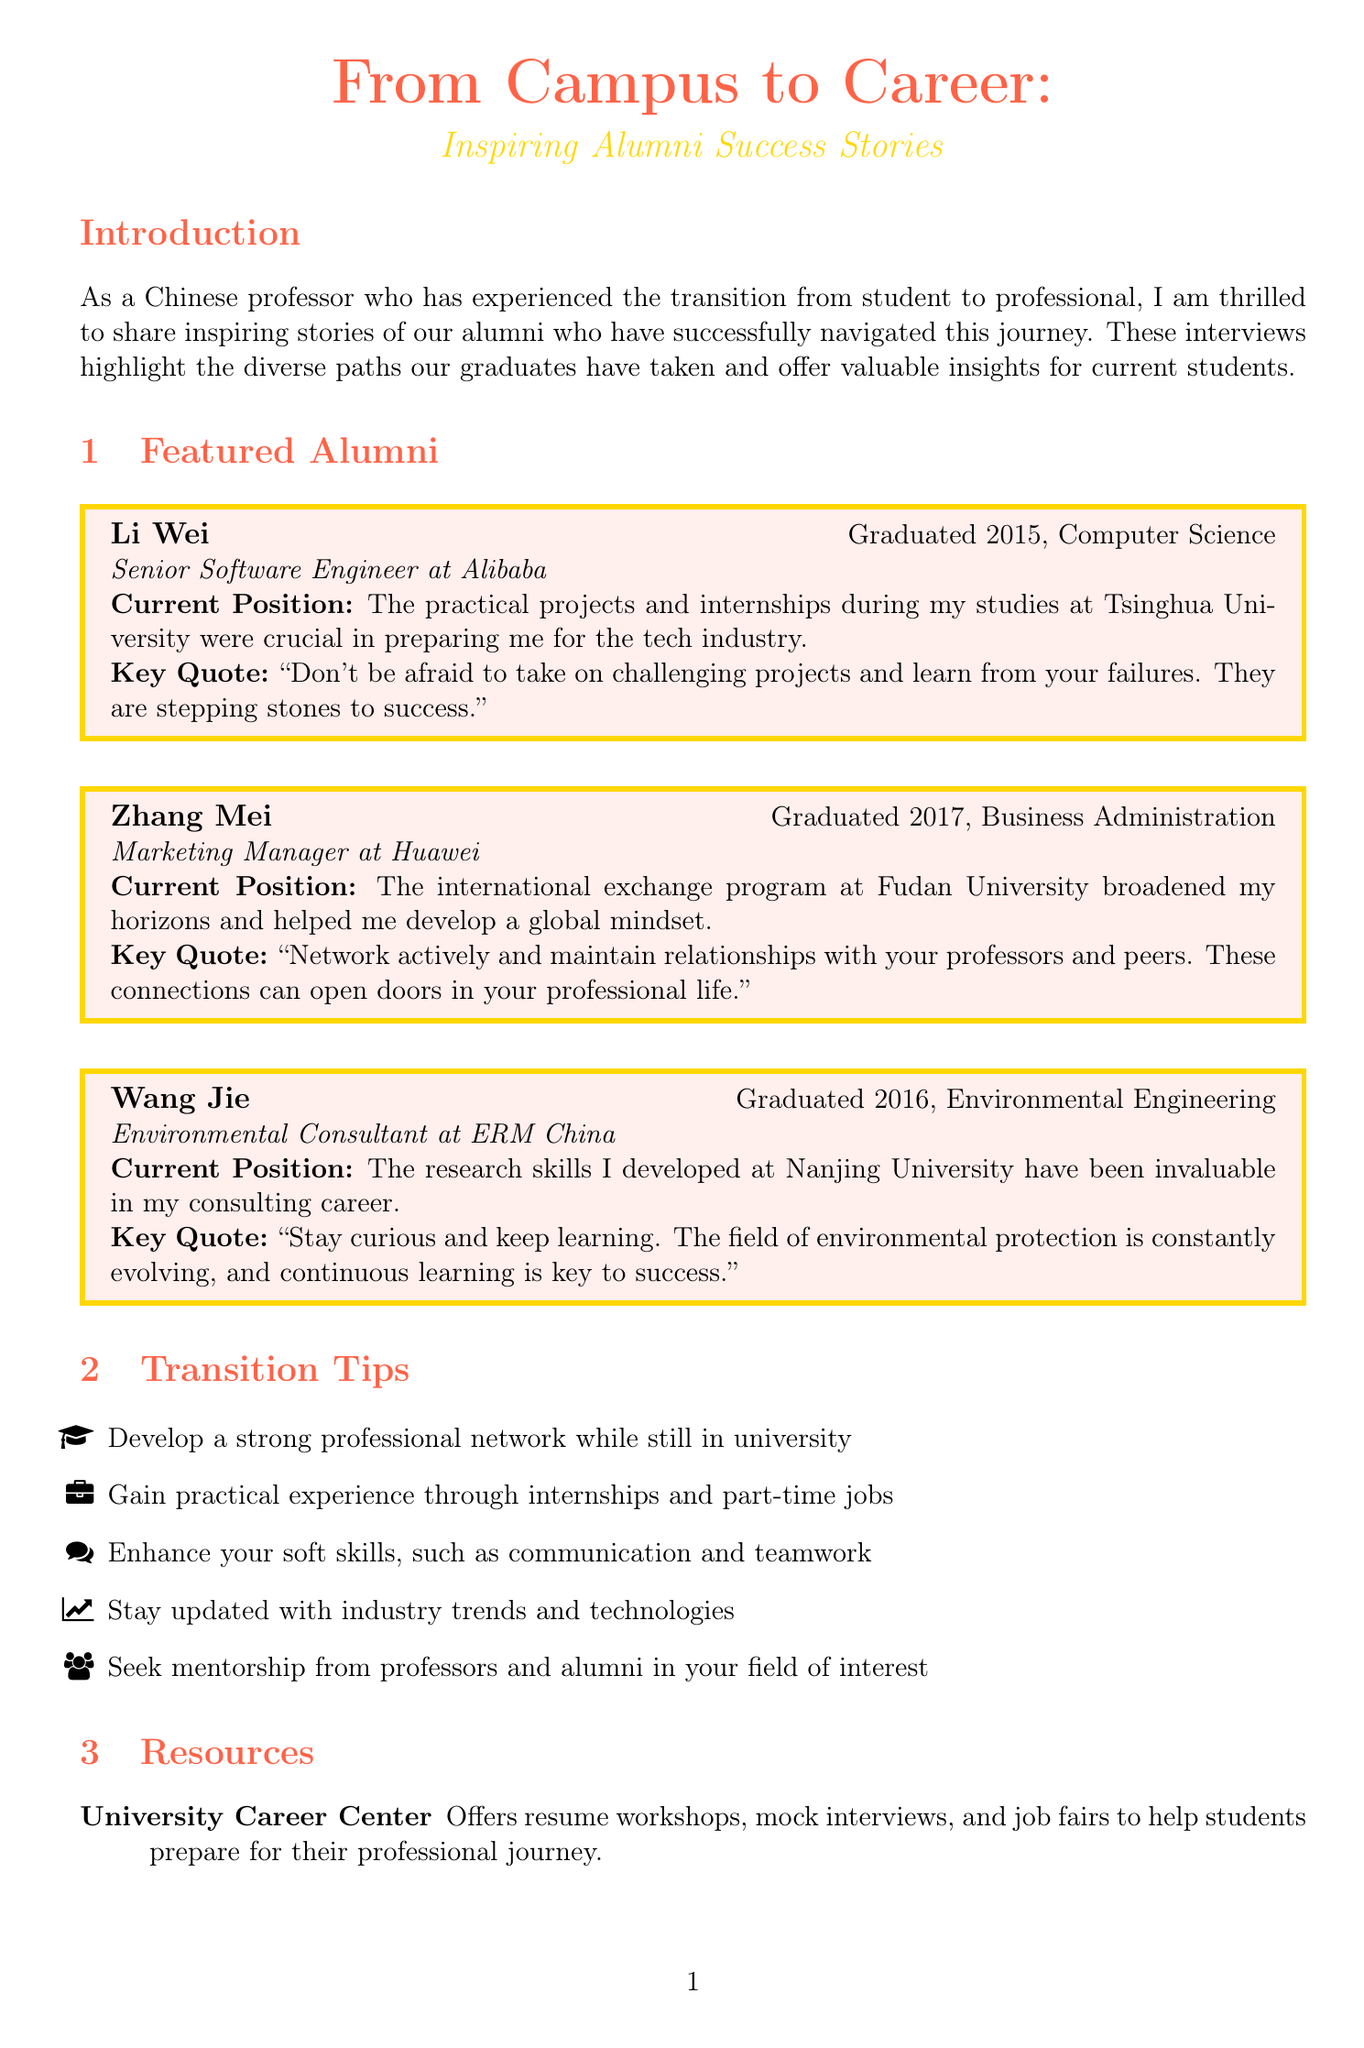what year did Li Wei graduate? Li Wei graduated in 2015, which is specified in the document.
Answer: 2015 what is Zhang Mei's current position? Zhang Mei is currently a Marketing Manager at Huawei, mentioned in her profile.
Answer: Marketing Manager at Huawei what major did Wang Jie study? Wang Jie majored in Environmental Engineering, as stated in the document.
Answer: Environmental Engineering what is a key quote from Li Wei? The document provides a quote from Li Wei highlighting the importance of practical projects during his studies.
Answer: The practical projects and internships during my studies at Tsinghua University were crucial in preparing me for the tech industry how many transition tips are listed in the document? The document enumerates five transition tips for students making their career move.
Answer: Five what resource connects students with successful alumni? The Alumni Mentorship Program connects current students with successful alumni for guidance, according to the document.
Answer: Alumni Mentorship Program what advice does Zhang Mei give to current students? Zhang Mei advises students to network actively and maintain relationships with their professors.
Answer: Network actively and maintain relationships with your professors and peers what university did Li Wei attend? Li Wei attended Tsinghua University, as mentioned in his profile.
Answer: Tsinghua University what is the title of the newsletter? The newsletter is titled "From Campus to Career: Inspiring Alumni Success Stories," which is stated at the beginning.
Answer: From Campus to Career: Inspiring Alumni Success Stories 